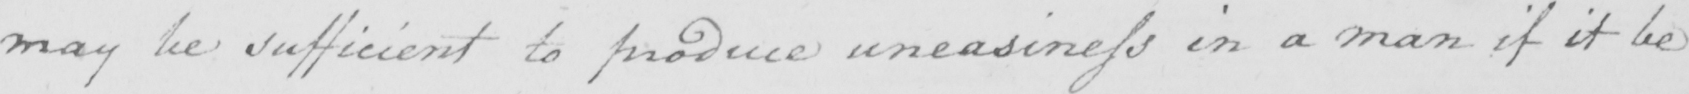What does this handwritten line say? may be sufficient to produce uneasiness in a man if it be 